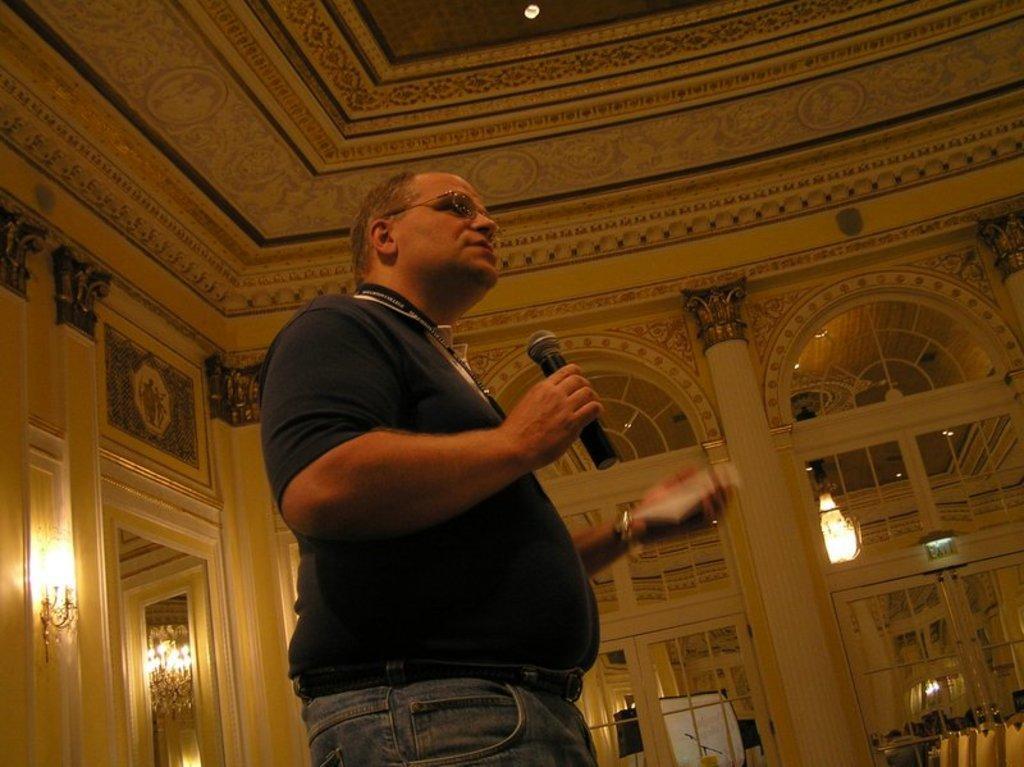Please provide a concise description of this image. In this picture there is a man in the center of the image, by holding a mic in his hand and there are lamps in the image and there are arches and mirrors in the image. 